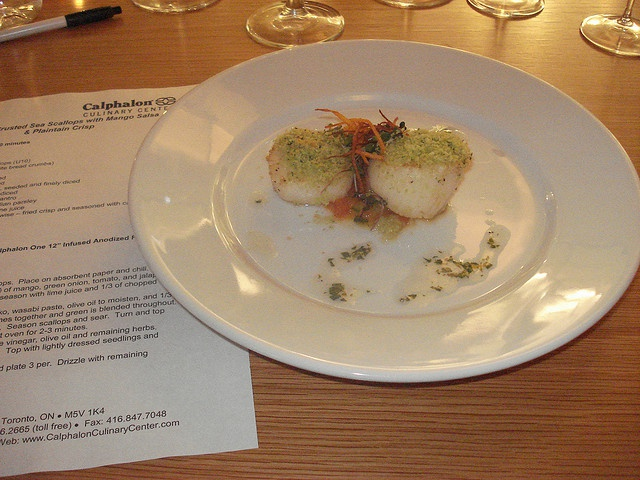Describe the objects in this image and their specific colors. I can see dining table in maroon, brown, and tan tones, book in maroon, darkgray, tan, and gray tones, wine glass in maroon, brown, gray, and tan tones, wine glass in maroon, olive, tan, and gray tones, and wine glass in maroon, tan, khaki, and gray tones in this image. 